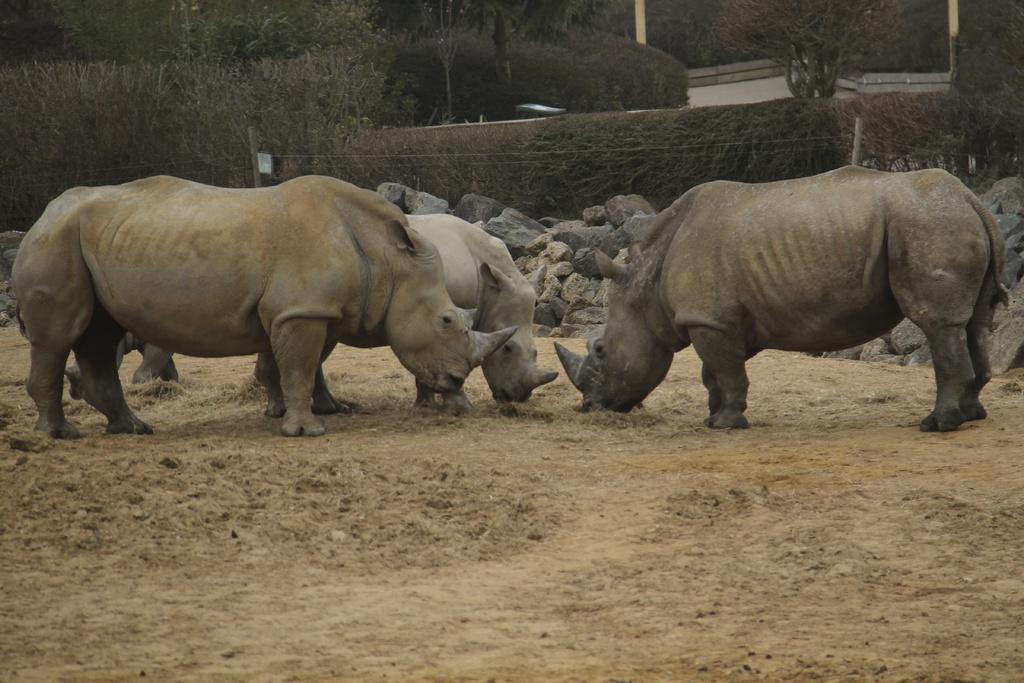How would you summarize this image in a sentence or two? In this image we can see rhinos standing on the ground. In the background there are stones, fences, poles and trees. 